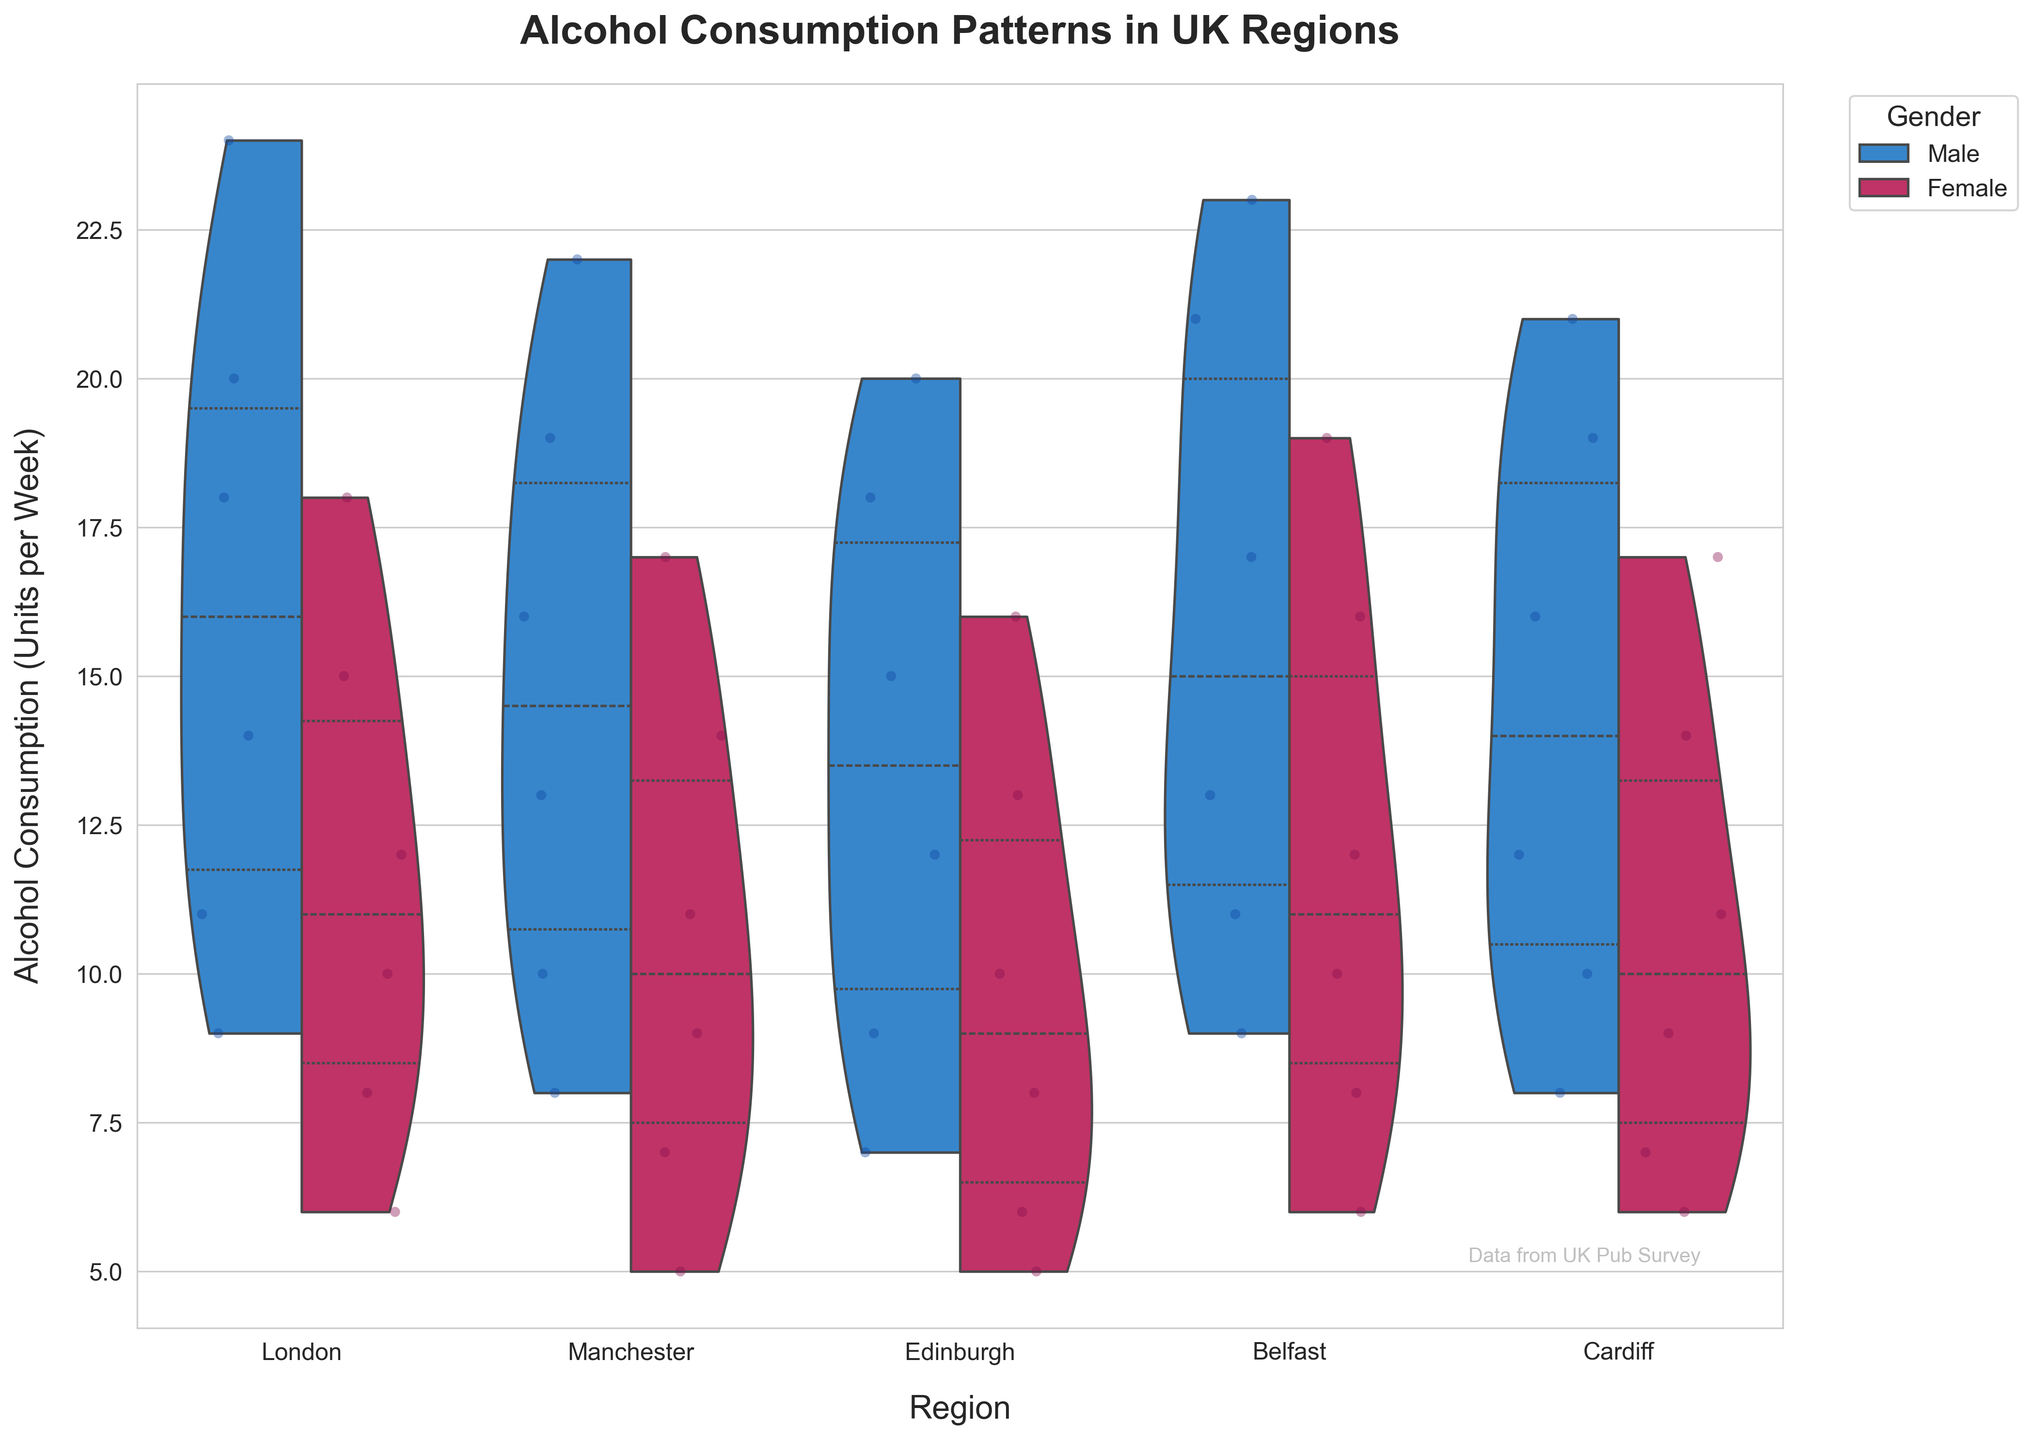what is the title of the figure The title of the figure is clearly labeled at the top of the chart. It states the main topic or theme of the visualization, specifically focusing on the subject matter displayed.
Answer: Alcohol Consumption Patterns in UK Regions Which region has the highest median alcohol consumption for males? The median value for each group is indicated by a line within the violin plot. We need to compare the positions of these medians for males across all regions.
Answer: London How does average alcohol consumption for males aged 18-24 in Belfast compare to that in Manchester? To compare average consumption, analyze the jittered points and the shape of the violins for 18-24 males in both Belfast and Manchester. Belfast visually shows higher average points compared to Manchester.
Answer: Higher in Belfast What does the "inner quartile" indicate in the violin plots? The inner quartile represents the interquartile range (IQR), which is the middle 50% of the data. In the plots, these are the areas that are thicker or highlighted between the 25th and 75th percentiles.
Answer: It shows the middle 50% of data Are there any regions where females consume more alcohol than males in any age group? For each region, compare the position and spread of the violin plots between males and females. Look for instances where the female violins are higher or have a larger spread.
Answer: No Which region appears to have the lowest variance in alcohol consumption for both genders? Variance is visually indicated by the width and spread of the violins and the range of the jittered points. Look for regions with the narrowest plots and least spread-out points.
Answer: Edinburgh What's the overall trend in alcohol consumption with increasing age across all regions? Analyze the spread and median lines of the violin plots by age across all regions. Look for a consistent trend in these features as age increases.
Answer: Decreasing trend In which region is the difference in median alcohol consumption between males and females largest? Compare the distances between median lines for males and females in each region's violin plots. Look for the region with the widest gap.
Answer: Belfast What can be inferred about the outliers in Belfast for males aged 18-24? Outliers are represented by points that fall far from the main area of the violin plot. Examine these points for Belfast males aged 18-24. They are significantly higher than the main distribution.
Answer: Some exceptionally high values How does Cardiff's alcohol consumption compare with Edinburgh's for the 45-54 age group across genders? Compare the positions and shapes of the violin plots for both Cardiff and Edinburgh in the 45-54 age range for both males and females. Cardiff shows slightly higher values for both genders than Edinburgh.
Answer: Higher in Cardiff 